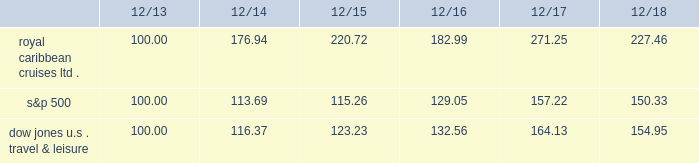Table of contents performance graph the following graph compares the total return , assuming reinvestment of dividends , on an investment in the company , based on performance of the company's common stock , with the total return of the standard & poor's 500 composite stock index ( "s&p 500" ) and the dow jones united states travel and leisure index for a five year period by measuring the changes in common stock prices from december 31 , 2013 to december 31 , 2018. .
The stock performance graph assumes for comparison that the value of the company's common stock and of each index was $ 100 on december 31 , 2013 and that all dividends were reinvested .
Past performance is not necessarily an indicator of future results. .
What was the percentage change in the royal caribbean cruises ltd . performance from 2014 to 2015? 
Computations: ((220.72 - 176.94) / 176.94)
Answer: 0.24743. 